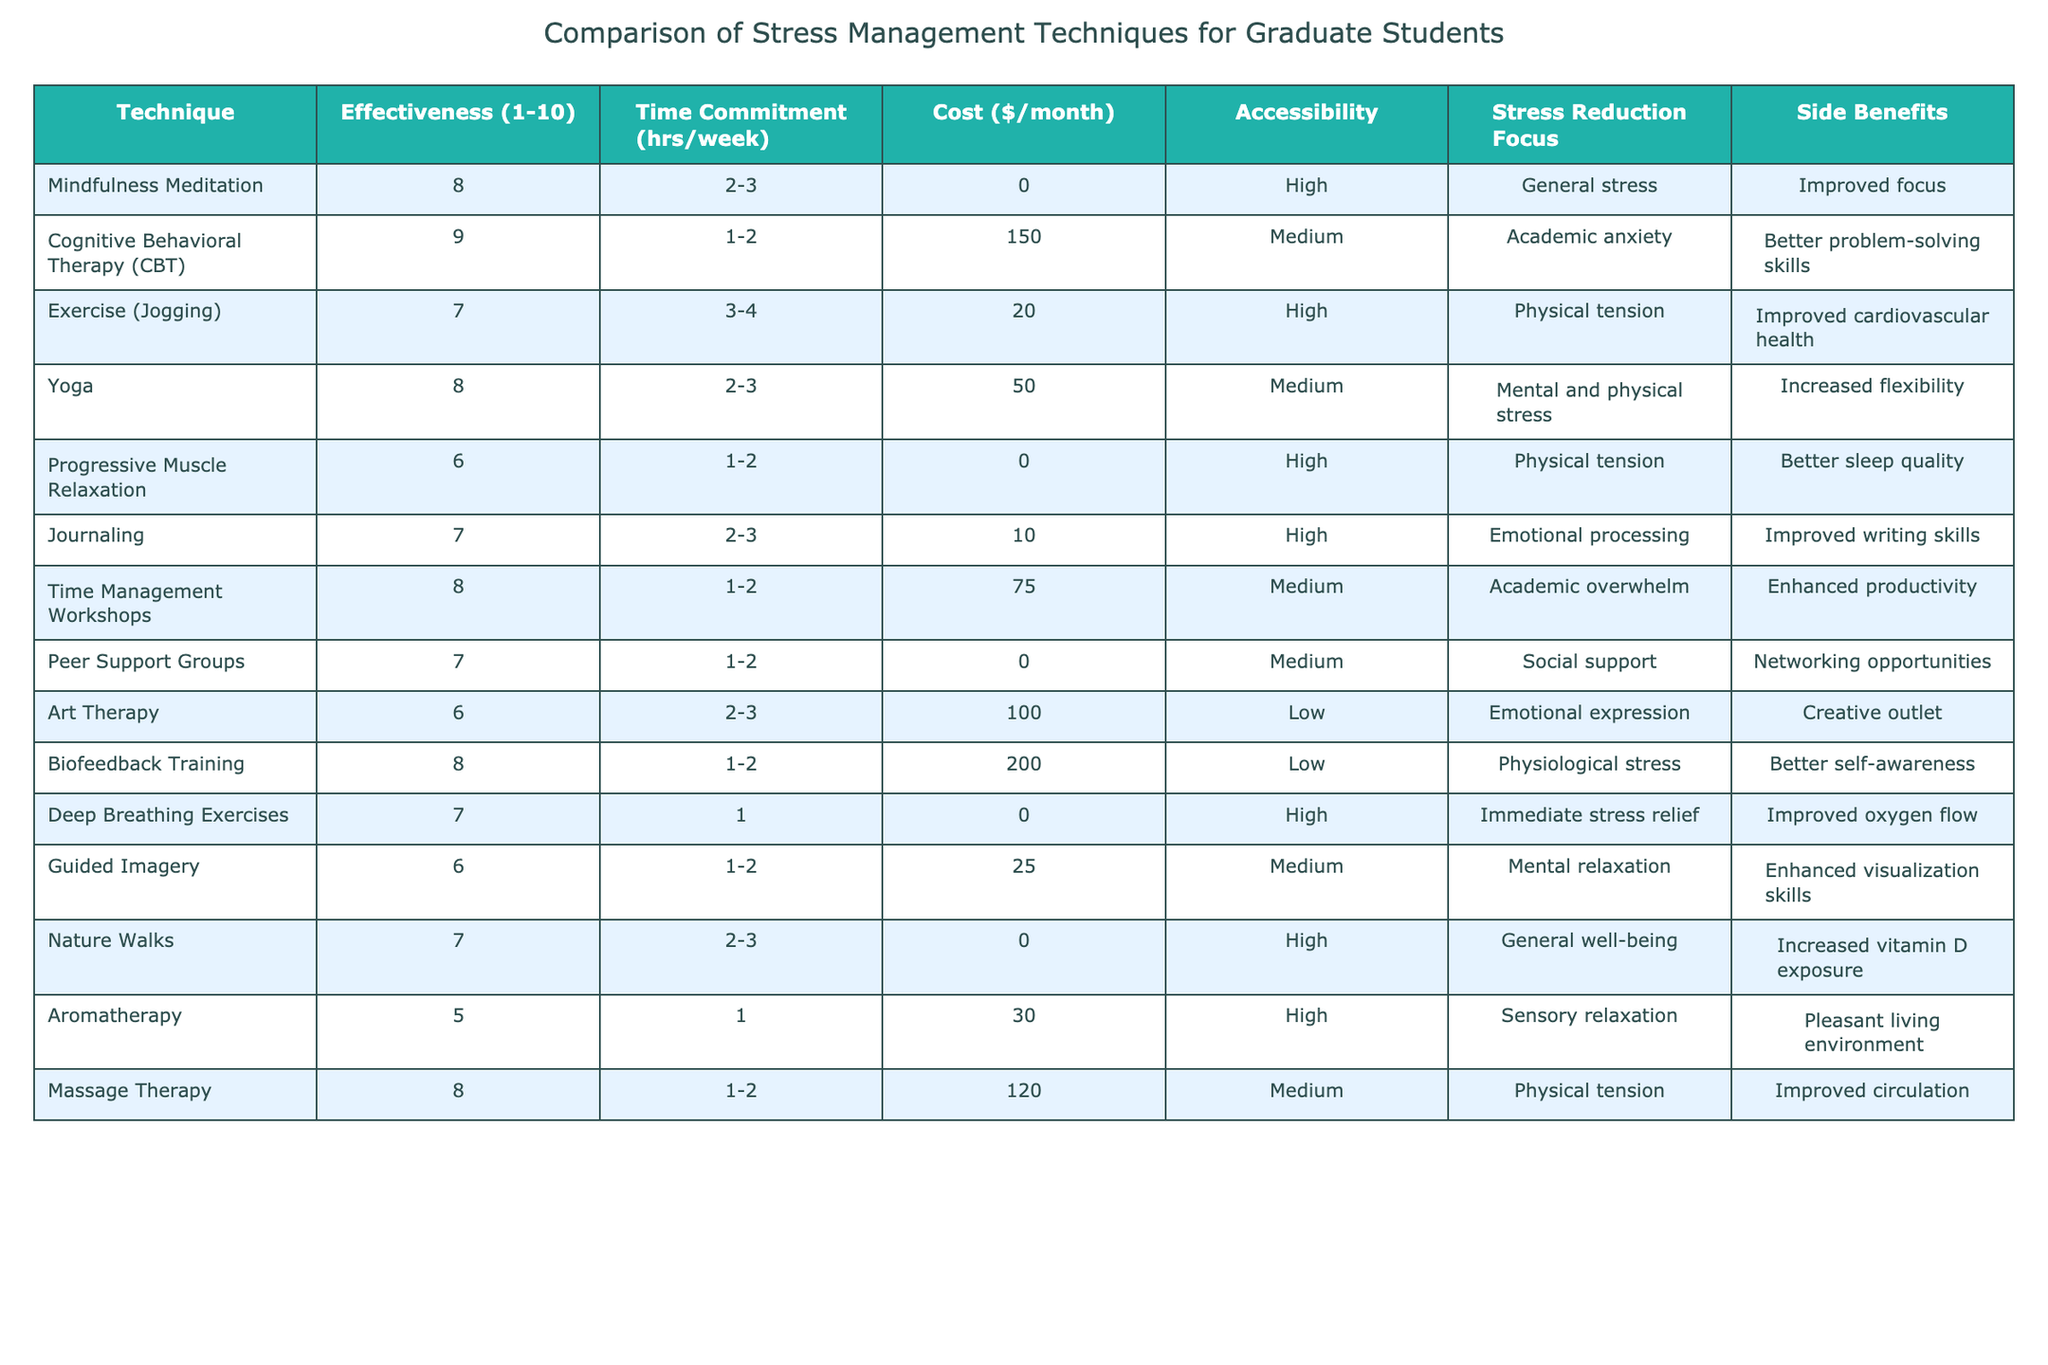What is the effectiveness rating of Cognitive Behavioral Therapy (CBT)? The table lists the effectiveness ratings of different techniques. For CBT, the rating is specifically noted as 9.
Answer: 9 Which technique has the highest cost per month? The table shows the costs associated with each technique. Upon checking, Biofeedback Training has the highest cost of $200 per month.
Answer: $200 Is Massage Therapy more accessible than Art Therapy? Accessibility for both techniques is listed. Massage Therapy is rated as Medium accessibility while Art Therapy is rated as Low accessibility. Therefore, Massage Therapy is more accessible.
Answer: Yes What is the average time commitment for the techniques related to emotional processing? The techniques focusing on emotional processing are Journaling and Art Therapy, which require 2-3 and 2-3 hours/week respectively. To find the average, we take the mid-point of 2.5 for both, resulting in an average of 2.5 hours/week.
Answer: 2.5 hours/week Which technique has the lowest effectiveness rating, and what is that rating? By reviewing the effectiveness ratings, we see Aromatherapy has the lowest effectiveness rating of 5.
Answer: 5 Do more techniques focus on physical tension or emotional processing? The techniques related to physical tension are Exercise, Progressive Muscle Relaxation, Massage Therapy, and Deep Breathing Exercises (a total of 4). The emotional processing techniques include Journaling and Art Therapy (a total of 2). Therefore, 4 techniques target physical tension.
Answer: Physical tension (4) What is the combined cost of using Time Management Workshops and Cognitive Behavioral Therapy (CBT) monthly? The costs for Time Management Workshops and CBT are $75 and $150, respectively. Adding these gives us a combined cost of $75 + $150 = $225 per month.
Answer: $225 Which technique offers the most side benefits, based on the diversity in benefits listed? The table can be analyzed for the variety of side benefits. Time Management Workshops have enhanced productivity and improved problem-solving skills, both considered significant benefits. Thus, it stands out for offering multiple benefits compared to others.
Answer: Time Management Workshops How many techniques have a high accessibility rating, and what are they? Checking the accessibility ratings, the techniques listed as having High accessibility are Mindfulness Meditation, Exercise, Deep Breathing Exercises, Nature Walks, and Journaling. Therefore, there are 5 techniques with high accessibility.
Answer: 5 